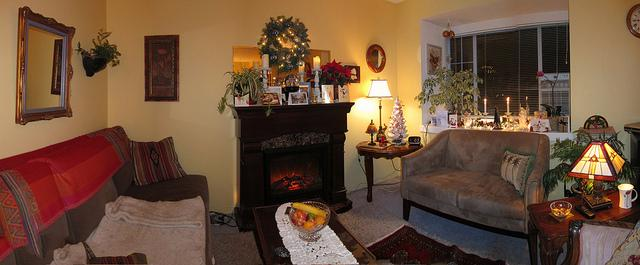What is the white object on the coffee table called? Please explain your reasoning. doily. It is a piece of decoration for the table. 